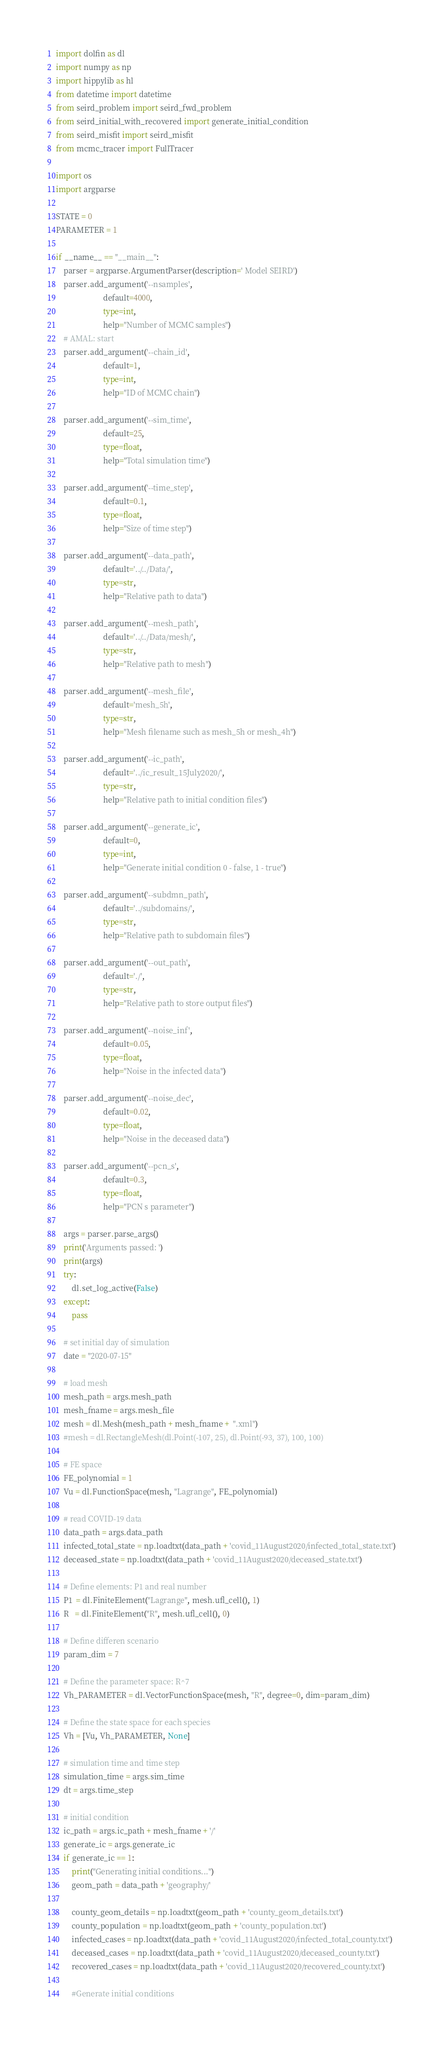Convert code to text. <code><loc_0><loc_0><loc_500><loc_500><_Python_>import dolfin as dl
import numpy as np
import hippylib as hl
from datetime import datetime
from seird_problem import seird_fwd_problem
from seird_initial_with_recovered import generate_initial_condition
from seird_misfit import seird_misfit
from mcmc_tracer import FullTracer

import os
import argparse

STATE = 0
PARAMETER = 1

if __name__ == "__main__":
    parser = argparse.ArgumentParser(description=' Model SEIRD')
    parser.add_argument('--nsamples',
                        default=4000,
                        type=int,
                        help="Number of MCMC samples")
    # AMAL: start
    parser.add_argument('--chain_id',
                        default=1,
                        type=int,
                        help="ID of MCMC chain")

    parser.add_argument('--sim_time',
                        default=25,
                        type=float,
                        help="Total simulation time")
    
    parser.add_argument('--time_step',
                        default=0.1,
                        type=float,
                        help="Size of time step")
                        
    parser.add_argument('--data_path',
                        default='../../Data/',
                        type=str,
                        help="Relative path to data")
                        
    parser.add_argument('--mesh_path',
                        default='../../Data/mesh/',
                        type=str,
                        help="Relative path to mesh")

    parser.add_argument('--mesh_file',
                        default='mesh_5h',
                        type=str,
                        help="Mesh filename such as mesh_5h or mesh_4h")
    
    parser.add_argument('--ic_path',
                        default='../ic_result_15July2020/',
                        type=str,
                        help="Relative path to initial condition files")

    parser.add_argument('--generate_ic',
                        default=0,
                        type=int,
                        help="Generate initial condition 0 - false, 1 - true")

    parser.add_argument('--subdmn_path',
                        default='../subdomains/',
                        type=str,
                        help="Relative path to subdomain files")
    
    parser.add_argument('--out_path',
                        default='./',
                        type=str,
                        help="Relative path to store output files")

    parser.add_argument('--noise_inf',
                        default=0.05,
                        type=float,
                        help="Noise in the infected data")

    parser.add_argument('--noise_dec',
                        default=0.02,
                        type=float,
                        help="Noise in the deceased data")

    parser.add_argument('--pcn_s',
                        default=0.3,
                        type=float,
                        help="PCN s parameter")
    
    args = parser.parse_args()
    print('Arguments passed: ')
    print(args)
    try:
        dl.set_log_active(False)
    except:
        pass

    # set initial day of simulation
    date = "2020-07-15"

    # load mesh
    mesh_path = args.mesh_path
    mesh_fname = args.mesh_file
    mesh = dl.Mesh(mesh_path + mesh_fname +  ".xml")
    #mesh = dl.RectangleMesh(dl.Point(-107, 25), dl.Point(-93, 37), 100, 100)

    # FE space
    FE_polynomial = 1
    Vu = dl.FunctionSpace(mesh, "Lagrange", FE_polynomial)

    # read COVID-19 data
    data_path = args.data_path
    infected_total_state = np.loadtxt(data_path + 'covid_11August2020/infected_total_state.txt')
    deceased_state = np.loadtxt(data_path + 'covid_11August2020/deceased_state.txt')
        
    # Define elements: P1 and real number
    P1  = dl.FiniteElement("Lagrange", mesh.ufl_cell(), 1)
    R   = dl.FiniteElement("R", mesh.ufl_cell(), 0)

    # Define differen scenario
    param_dim = 7

    # Define the parameter space: R^7
    Vh_PARAMETER = dl.VectorFunctionSpace(mesh, "R", degree=0, dim=param_dim)

    # Define the state space for each species
    Vh = [Vu, Vh_PARAMETER, None]

    # simulation time and time step
    simulation_time = args.sim_time
    dt = args.time_step

    # initial condition
    ic_path = args.ic_path + mesh_fname + '/'
    generate_ic = args.generate_ic
    if generate_ic == 1:
        print("Generating initial conditions...")
        geom_path = data_path + 'geography/'

        county_geom_details = np.loadtxt(geom_path + 'county_geom_details.txt')
        county_population = np.loadtxt(geom_path + 'county_population.txt')
        infected_cases = np.loadtxt(data_path + 'covid_11August2020/infected_total_county.txt')
        deceased_cases = np.loadtxt(data_path + 'covid_11August2020/deceased_county.txt')
        recovered_cases = np.loadtxt(data_path + 'covid_11August2020/recovered_county.txt')

        #Generate initial conditions</code> 